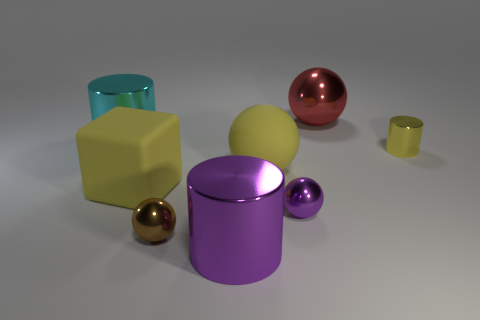What is the shape of the small purple object that is made of the same material as the brown sphere?
Offer a very short reply. Sphere. Is there any other thing that is the same color as the rubber block?
Your answer should be compact. Yes. Do the large red thing and the brown object have the same material?
Offer a terse response. Yes. There is a metal object right of the big red sphere; is there a yellow matte object that is behind it?
Provide a succinct answer. No. Are there any large things that have the same shape as the tiny purple metal object?
Your answer should be compact. Yes. Is the color of the large shiny sphere the same as the large cube?
Your answer should be compact. No. What material is the small object left of the big cylinder in front of the cyan cylinder?
Keep it short and to the point. Metal. What is the size of the purple metal ball?
Provide a succinct answer. Small. There is a purple ball that is made of the same material as the cyan object; what is its size?
Provide a short and direct response. Small. Do the metal thing behind the cyan metal thing and the purple cylinder have the same size?
Keep it short and to the point. Yes. 